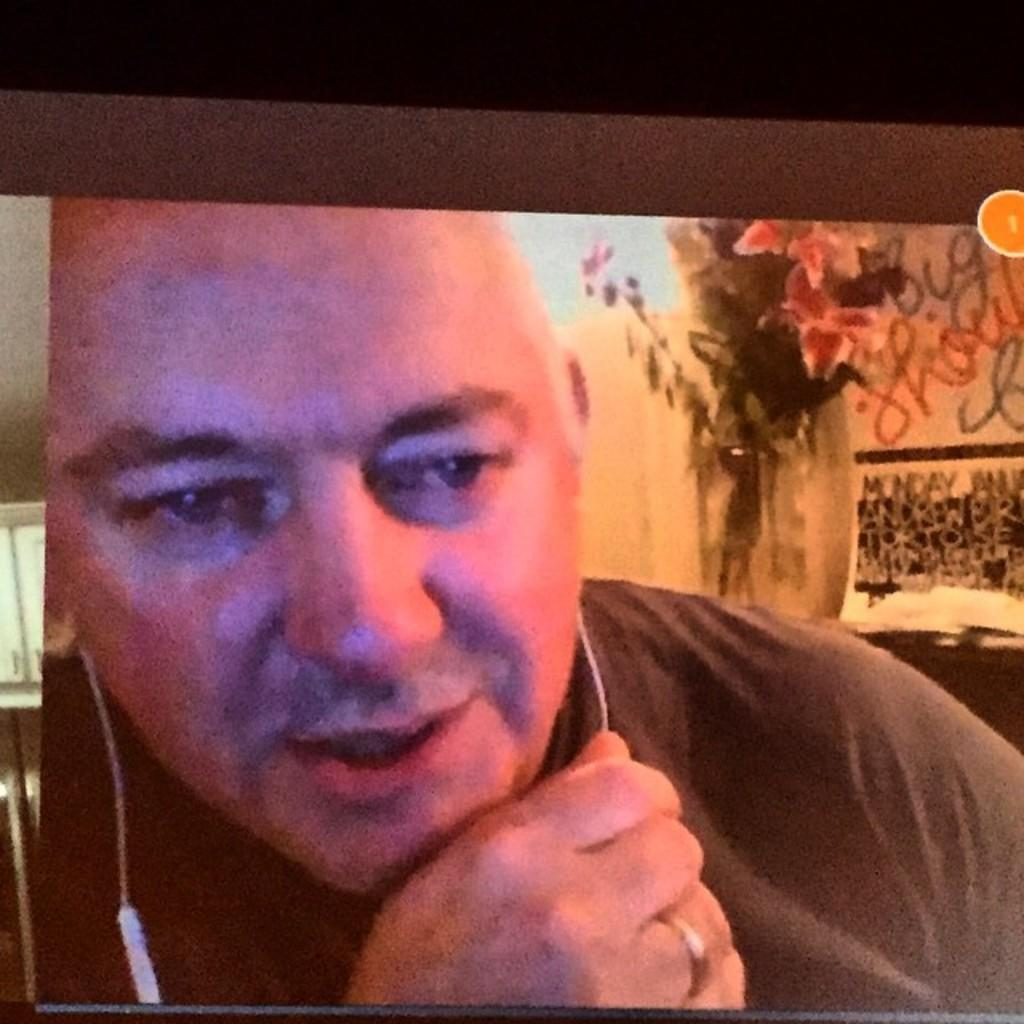Who is present in the image? There is a man in the image. What is the man wearing on his ears? The man is wearing headphones. What type of clothing is the man wearing on his upper body? The man is wearing a t-shirt. What can be seen in the background of the image? There are flowers and other objects visible in the background of the image. What is the size of the fictional character in the image? There is no fictional character present in the image; it features a man wearing headphones and a t-shirt. 